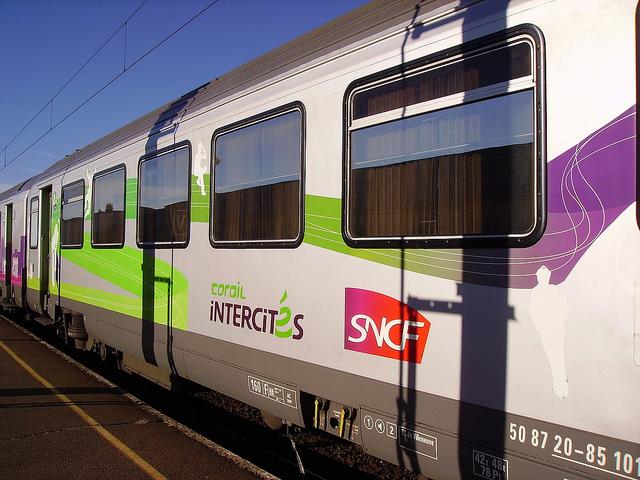What is the train parked beside?
Concise answer only. Road. Is the train pictured a passenger train or a freight train?
Be succinct. Passenger. How many train windows are visible?
Give a very brief answer. 6. What is the second number is the sequence on the train car?
Write a very short answer. 0. Is it sunny?
Give a very brief answer. Yes. 